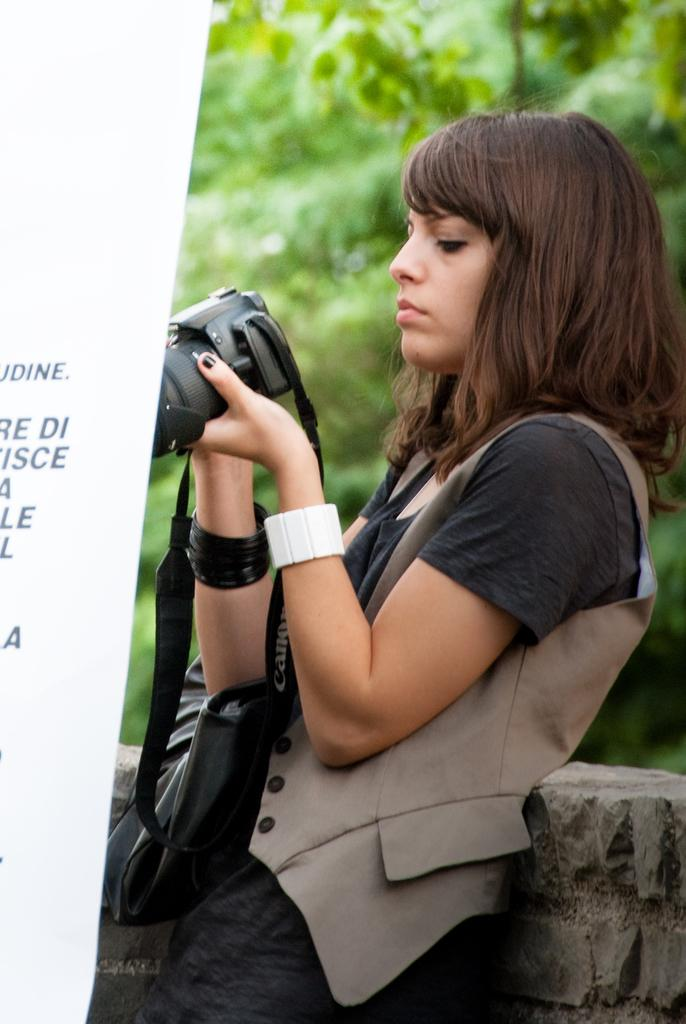What is present in the image besides the woman? There is a tree in the image. What is the woman holding in the image? The woman is holding a camera. Is there a wound visible on the tree in the image? There is no mention of a wound on the tree in the image, and it cannot be determined from the provided facts. 